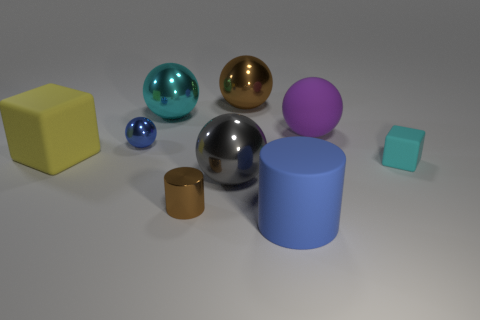Are there any small things that have the same color as the large cylinder?
Make the answer very short. Yes. There is a big thing that is in front of the cyan matte cube and on the left side of the large blue cylinder; what color is it?
Keep it short and to the point. Gray. What is the size of the yellow object?
Offer a very short reply. Large. There is a tiny thing behind the yellow object; is it the same color as the rubber cylinder?
Provide a short and direct response. Yes. Is the number of big balls in front of the small blue object greater than the number of large brown objects that are on the left side of the large cyan sphere?
Your answer should be compact. Yes. Are there more big rubber objects than big objects?
Your response must be concise. No. How big is the matte object that is in front of the yellow rubber block and on the left side of the tiny block?
Your response must be concise. Large. The gray object has what shape?
Provide a short and direct response. Sphere. Is there any other thing that has the same size as the purple matte thing?
Make the answer very short. Yes. Is the number of cyan rubber blocks that are in front of the big yellow cube greater than the number of tiny purple metallic balls?
Give a very brief answer. Yes. 